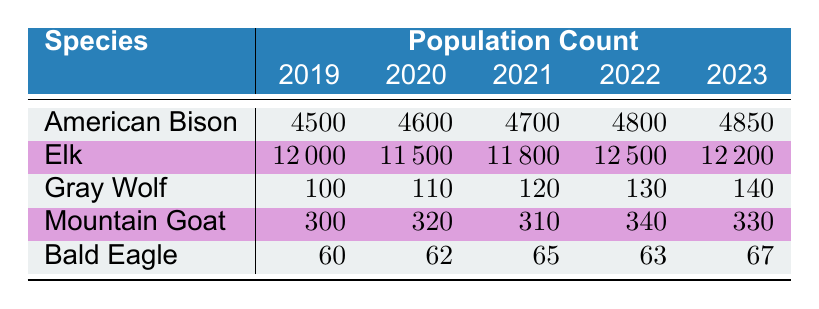What was the population count of the Gray Wolf in 2022? The table shows the population count for the Gray Wolf in 2022 directly, which is indicated in the corresponding row for that year. The value listed is 130.
Answer: 130 What species had the highest population count in 2019? By reviewing the table, we can see that the species populations for 2019 are as follows: American Bison (4500), Elk (12000), Gray Wolf (100), Mountain Goat (300), Bald Eagle (60). The highest count is for the Elk at 12000.
Answer: Elk How many American Bison were there in total from 2019 to 2023? To find the total population of American Bison over the five years, we need to sum the respective values: 4500 (2019) + 4600 (2020) + 4700 (2021) + 4800 (2022) + 4850 (2023) = 23450.
Answer: 23450 Did the population of Mountain Goats increase every year from 2019 to 2023? We examine the table for the Mountain Goat populations: 300 (2019), 320 (2020), 310 (2021), 340 (2022), and 330 (2023). The population increased from 2019 to 2020, then decreased in 2021, increased in 2022, and again decreased in 2023, so it did not increase every year.
Answer: No What is the average population count of the Bald Eagle from 2019 to 2023? To find the average, we first sum the population counts: 60 + 62 + 65 + 63 + 67 = 317. Then, we divide by the number of years, which is 5: 317 / 5 = 63.4.
Answer: 63.4 